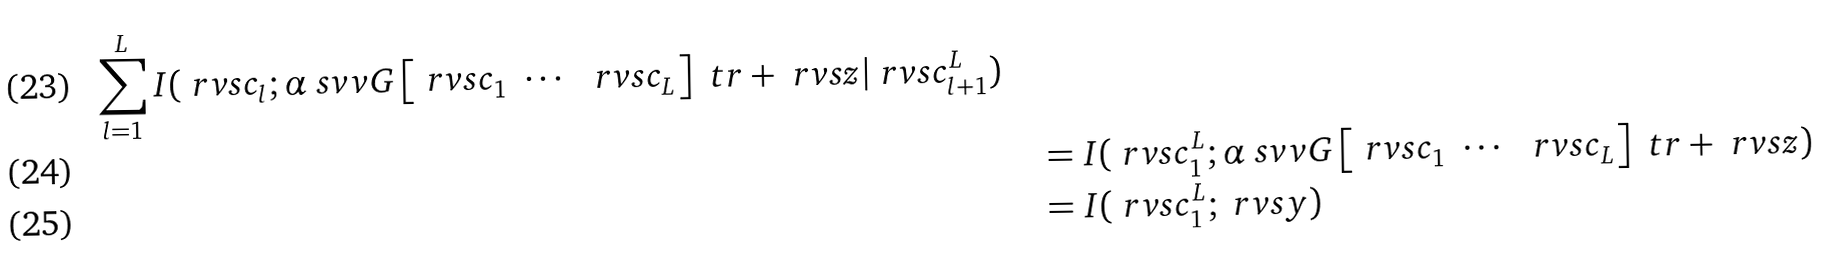<formula> <loc_0><loc_0><loc_500><loc_500>{ \sum _ { l = 1 } ^ { L } I ( \ r v s { c } _ { l } ; \alpha \ s v v { G } \begin{bmatrix} \ r v s { c } _ { 1 } & \cdots & \ r v s { c } _ { L } \end{bmatrix} ^ { \ } t r + \ r v s { z } | \ r v s { c } _ { l + 1 } ^ { L } ) } \quad \\ & = I ( \ r v s { c } _ { 1 } ^ { L } ; \alpha \ s v v { G } \begin{bmatrix} \ r v s { c } _ { 1 } & \cdots & \ r v s { c } _ { L } \end{bmatrix} ^ { \ } t r + \ r v s { z } ) \\ & = I ( \ r v s { c } _ { 1 } ^ { L } ; \ r v s { y } )</formula> 